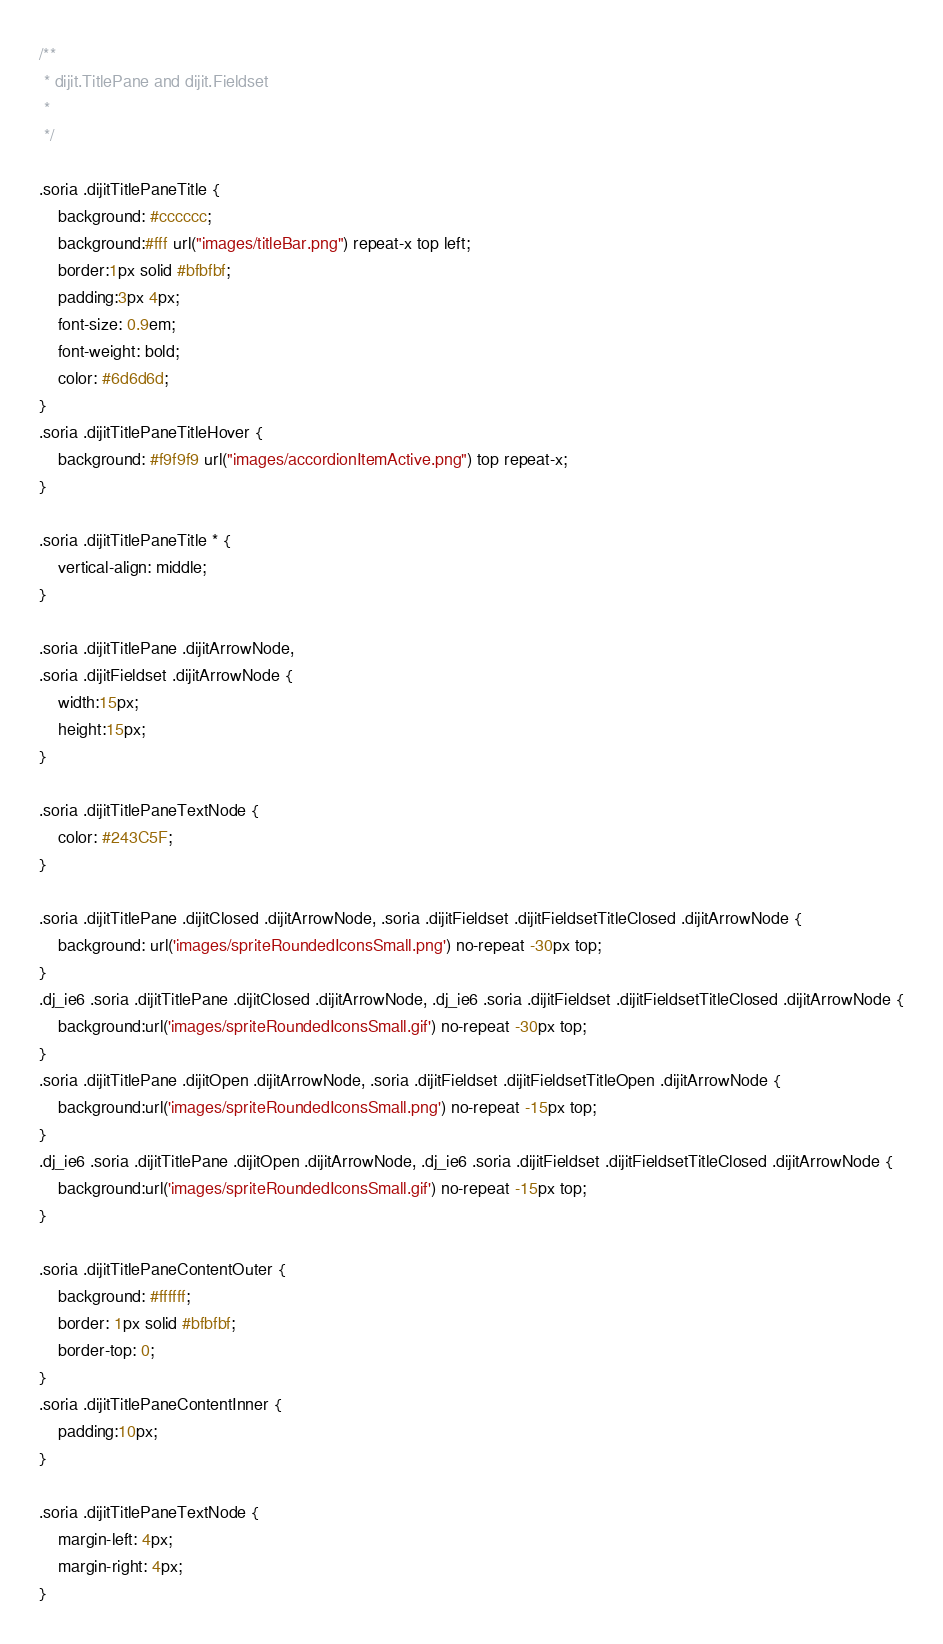Convert code to text. <code><loc_0><loc_0><loc_500><loc_500><_CSS_>/**
 * dijit.TitlePane and dijit.Fieldset
 *
 */

.soria .dijitTitlePaneTitle {
	background: #cccccc;
	background:#fff url("images/titleBar.png") repeat-x top left;
	border:1px solid #bfbfbf;
	padding:3px 4px;
	font-size: 0.9em;
	font-weight: bold;
	color: #6d6d6d;
}
.soria .dijitTitlePaneTitleHover {
	background: #f9f9f9 url("images/accordionItemActive.png") top repeat-x;
}

.soria .dijitTitlePaneTitle * {
	vertical-align: middle;
}

.soria .dijitTitlePane .dijitArrowNode,
.soria .dijitFieldset .dijitArrowNode {
	width:15px;
	height:15px;
}

.soria .dijitTitlePaneTextNode {
	color: #243C5F;
}

.soria .dijitTitlePane .dijitClosed .dijitArrowNode, .soria .dijitFieldset .dijitFieldsetTitleClosed .dijitArrowNode {
	background: url('images/spriteRoundedIconsSmall.png') no-repeat -30px top;
}
.dj_ie6 .soria .dijitTitlePane .dijitClosed .dijitArrowNode, .dj_ie6 .soria .dijitFieldset .dijitFieldsetTitleClosed .dijitArrowNode {
	background:url('images/spriteRoundedIconsSmall.gif') no-repeat -30px top;
}
.soria .dijitTitlePane .dijitOpen .dijitArrowNode, .soria .dijitFieldset .dijitFieldsetTitleOpen .dijitArrowNode {
	background:url('images/spriteRoundedIconsSmall.png') no-repeat -15px top;
}
.dj_ie6 .soria .dijitTitlePane .dijitOpen .dijitArrowNode, .dj_ie6 .soria .dijitFieldset .dijitFieldsetTitleClosed .dijitArrowNode {
	background:url('images/spriteRoundedIconsSmall.gif') no-repeat -15px top;
}

.soria .dijitTitlePaneContentOuter {
	background: #ffffff;
	border: 1px solid #bfbfbf;
	border-top: 0;
}
.soria .dijitTitlePaneContentInner {
	padding:10px;
}

.soria .dijitTitlePaneTextNode {
	margin-left: 4px;
	margin-right: 4px;
}
</code> 